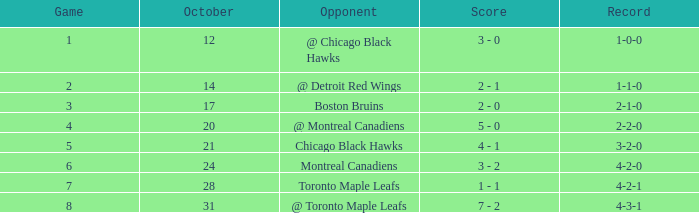Before facing the chicago blackhawks in game 6, what was the game record? 3-2-0. Could you parse the entire table? {'header': ['Game', 'October', 'Opponent', 'Score', 'Record'], 'rows': [['1', '12', '@ Chicago Black Hawks', '3 - 0', '1-0-0'], ['2', '14', '@ Detroit Red Wings', '2 - 1', '1-1-0'], ['3', '17', 'Boston Bruins', '2 - 0', '2-1-0'], ['4', '20', '@ Montreal Canadiens', '5 - 0', '2-2-0'], ['5', '21', 'Chicago Black Hawks', '4 - 1', '3-2-0'], ['6', '24', 'Montreal Canadiens', '3 - 2', '4-2-0'], ['7', '28', 'Toronto Maple Leafs', '1 - 1', '4-2-1'], ['8', '31', '@ Toronto Maple Leafs', '7 - 2', '4-3-1']]} 